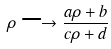Convert formula to latex. <formula><loc_0><loc_0><loc_500><loc_500>\rho \longrightarrow \frac { a \rho + b } { c \rho + d }</formula> 